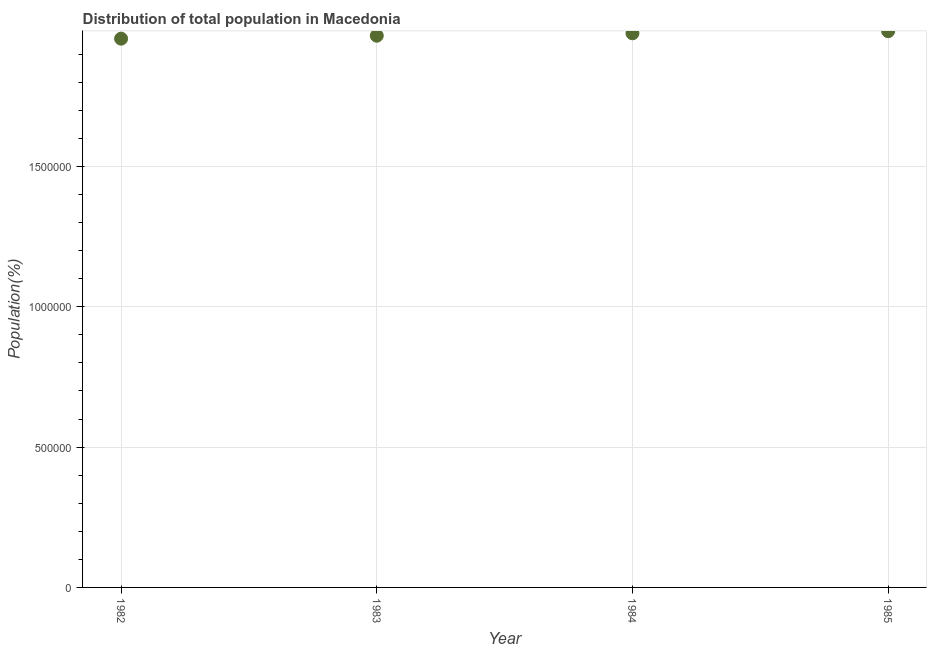What is the population in 1984?
Provide a short and direct response. 1.97e+06. Across all years, what is the maximum population?
Your answer should be compact. 1.98e+06. Across all years, what is the minimum population?
Make the answer very short. 1.95e+06. In which year was the population maximum?
Your answer should be very brief. 1985. In which year was the population minimum?
Keep it short and to the point. 1982. What is the sum of the population?
Provide a short and direct response. 7.88e+06. What is the difference between the population in 1982 and 1983?
Provide a succinct answer. -1.05e+04. What is the average population per year?
Offer a terse response. 1.97e+06. What is the median population?
Ensure brevity in your answer.  1.97e+06. What is the ratio of the population in 1983 to that in 1985?
Your response must be concise. 0.99. What is the difference between the highest and the second highest population?
Keep it short and to the point. 7463. Is the sum of the population in 1984 and 1985 greater than the maximum population across all years?
Provide a short and direct response. Yes. What is the difference between the highest and the lowest population?
Your answer should be very brief. 2.65e+04. In how many years, is the population greater than the average population taken over all years?
Your answer should be very brief. 2. Does the population monotonically increase over the years?
Provide a succinct answer. Yes. How many dotlines are there?
Your response must be concise. 1. How many years are there in the graph?
Provide a short and direct response. 4. Are the values on the major ticks of Y-axis written in scientific E-notation?
Provide a succinct answer. No. Does the graph contain grids?
Offer a very short reply. Yes. What is the title of the graph?
Your answer should be very brief. Distribution of total population in Macedonia . What is the label or title of the Y-axis?
Your answer should be compact. Population(%). What is the Population(%) in 1982?
Provide a succinct answer. 1.95e+06. What is the Population(%) in 1983?
Provide a succinct answer. 1.97e+06. What is the Population(%) in 1984?
Your response must be concise. 1.97e+06. What is the Population(%) in 1985?
Provide a short and direct response. 1.98e+06. What is the difference between the Population(%) in 1982 and 1983?
Your response must be concise. -1.05e+04. What is the difference between the Population(%) in 1982 and 1984?
Keep it short and to the point. -1.91e+04. What is the difference between the Population(%) in 1982 and 1985?
Provide a short and direct response. -2.65e+04. What is the difference between the Population(%) in 1983 and 1984?
Offer a very short reply. -8581. What is the difference between the Population(%) in 1983 and 1985?
Your response must be concise. -1.60e+04. What is the difference between the Population(%) in 1984 and 1985?
Your response must be concise. -7463. What is the ratio of the Population(%) in 1982 to that in 1983?
Offer a very short reply. 0.99. What is the ratio of the Population(%) in 1982 to that in 1985?
Provide a short and direct response. 0.99. What is the ratio of the Population(%) in 1983 to that in 1985?
Your answer should be compact. 0.99. What is the ratio of the Population(%) in 1984 to that in 1985?
Provide a short and direct response. 1. 